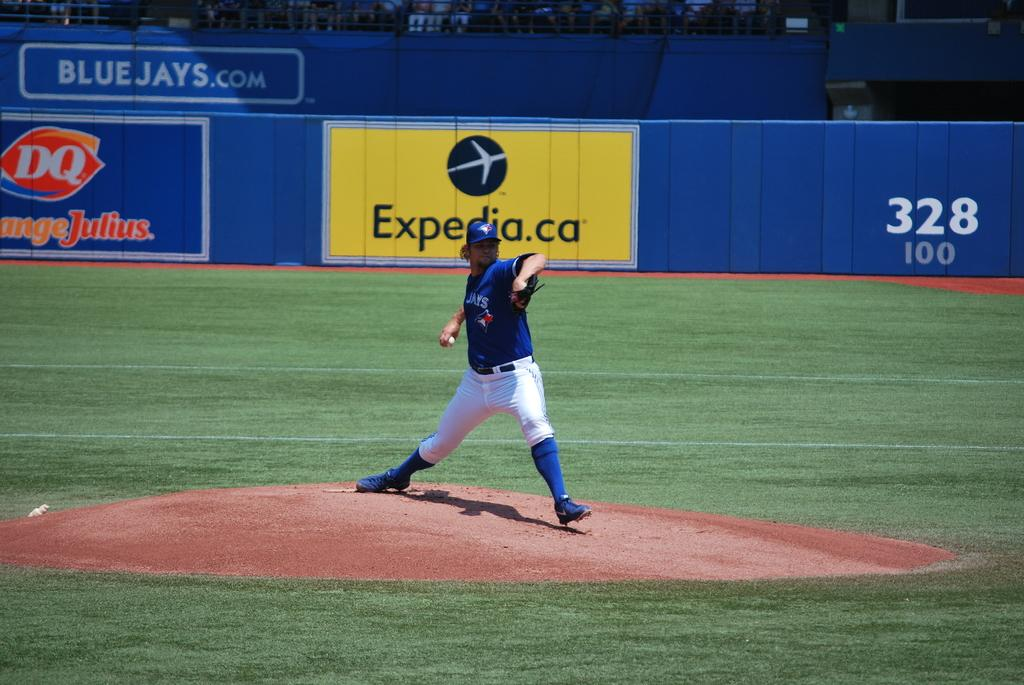<image>
Provide a brief description of the given image. A baseball pitcher pitching and wearing a blue jersey that says Blue Jays on it. 